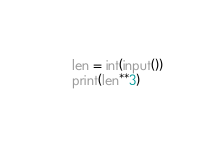<code> <loc_0><loc_0><loc_500><loc_500><_Python_>len = int(input())
print(len**3)
</code> 